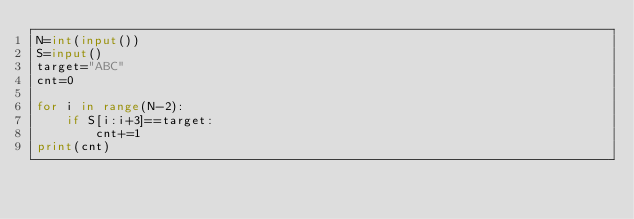<code> <loc_0><loc_0><loc_500><loc_500><_Python_>N=int(input())
S=input()
target="ABC"
cnt=0

for i in range(N-2):
    if S[i:i+3]==target:
        cnt+=1
print(cnt)
</code> 